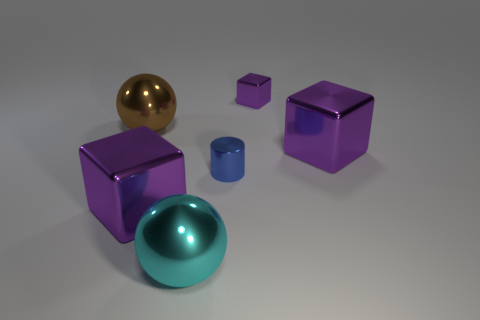There is a small cube; is its color the same as the big shiny thing on the right side of the tiny purple shiny thing?
Make the answer very short. Yes. There is a small purple object that is the same material as the blue cylinder; what shape is it?
Your response must be concise. Cube. What number of large red metallic cubes are there?
Provide a succinct answer. 0. What number of things are either large things in front of the big brown sphere or big purple spheres?
Your answer should be very brief. 3. There is a big shiny object that is to the right of the tiny purple metallic thing; is its color the same as the small block?
Keep it short and to the point. Yes. How many other objects are there of the same color as the small block?
Your response must be concise. 2. How many big things are cylinders or blue rubber objects?
Keep it short and to the point. 0. Are there more brown objects than purple cylinders?
Offer a terse response. Yes. Is the number of large brown shiny balls right of the brown object greater than the number of blue matte things?
Give a very brief answer. No. How many other large brown objects are the same shape as the brown metallic thing?
Give a very brief answer. 0. 